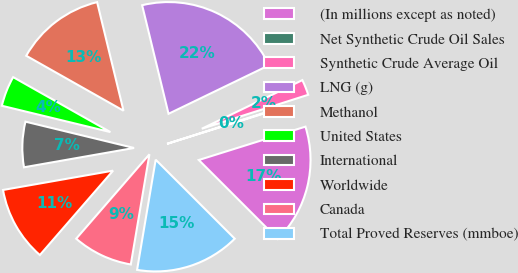Convert chart to OTSL. <chart><loc_0><loc_0><loc_500><loc_500><pie_chart><fcel>(In millions except as noted)<fcel>Net Synthetic Crude Oil Sales<fcel>Synthetic Crude Average Oil<fcel>LNG (g)<fcel>Methanol<fcel>United States<fcel>International<fcel>Worldwide<fcel>Canada<fcel>Total Proved Reserves (mmboe)<nl><fcel>17.32%<fcel>0.09%<fcel>2.25%<fcel>21.63%<fcel>13.02%<fcel>4.4%<fcel>6.55%<fcel>10.86%<fcel>8.71%<fcel>15.17%<nl></chart> 